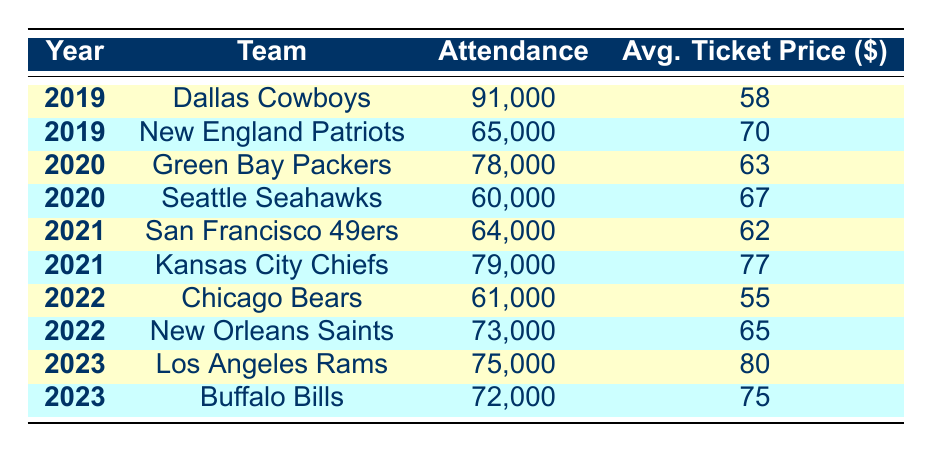What was the attendance for the Dallas Cowboys in 2019? The table shows that in 2019, the Dallas Cowboys had an attendance of 91,000.
Answer: 91,000 Which team had the highest average ticket price in 2021? By comparing the average ticket prices in 2021, the Kansas City Chiefs had the highest average ticket price of 77.
Answer: Kansas City Chiefs, 77 How many games had an attendance above 70,000 in 2022? In 2022, the teams with attendance above 70,000 were the New Orleans Saints (73,000). Chicago Bears had attendance of 61,000, which is below 70,000. Thus, there is only 1 game above 70,000.
Answer: 1 What is the average attendance for all teams over the last five years? To calculate the average attendance: Add all attendances (91,000 + 65,000 + 78,000 + 60,000 + 64,000 + 79,000 + 61,000 + 73,000 + 75,000 + 72,000 =  820,000) and then divide by the number of games (10). Average attendance = 820,000 / 10 = 82,000.
Answer: 82,000 Did the average ticket price decrease from 2021 to 2022 for the San Francisco 49ers? The average ticket price for the San Francisco 49ers in 2021 was 62, while it was 55 in 2022. Since 55 is less than 62, the ticket price did decrease.
Answer: Yes 